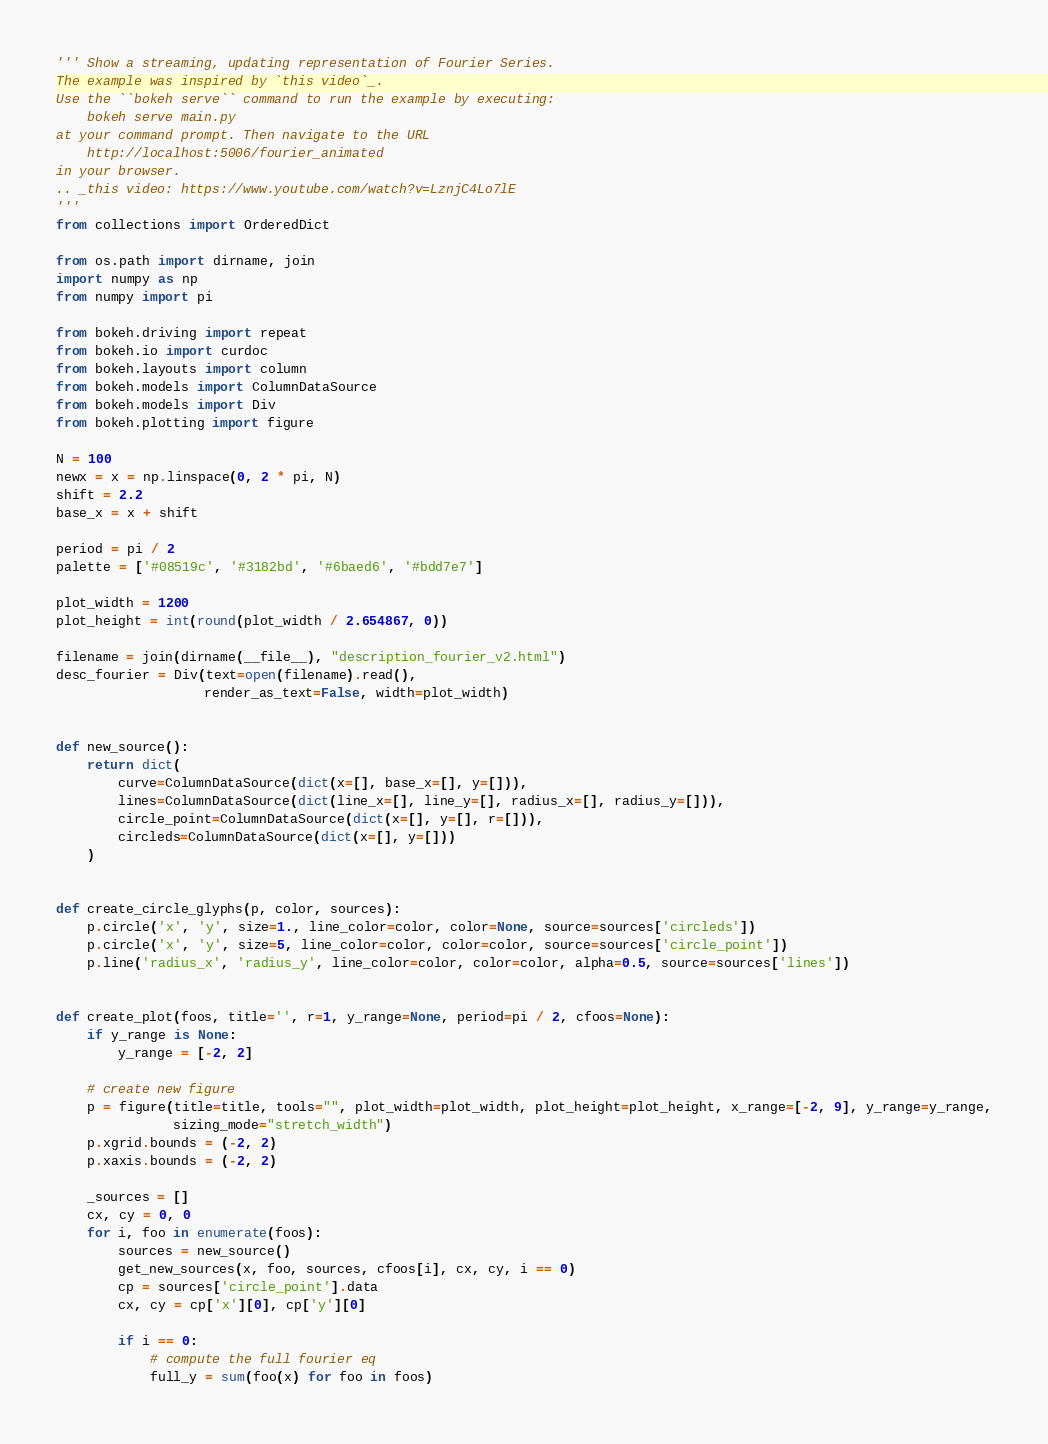Convert code to text. <code><loc_0><loc_0><loc_500><loc_500><_Python_>''' Show a streaming, updating representation of Fourier Series.
The example was inspired by `this video`_.
Use the ``bokeh serve`` command to run the example by executing:
    bokeh serve main.py
at your command prompt. Then navigate to the URL
    http://localhost:5006/fourier_animated
in your browser.
.. _this video: https://www.youtube.com/watch?v=LznjC4Lo7lE
'''
from collections import OrderedDict

from os.path import dirname, join
import numpy as np
from numpy import pi

from bokeh.driving import repeat
from bokeh.io import curdoc
from bokeh.layouts import column
from bokeh.models import ColumnDataSource
from bokeh.models import Div
from bokeh.plotting import figure

N = 100
newx = x = np.linspace(0, 2 * pi, N)
shift = 2.2
base_x = x + shift

period = pi / 2
palette = ['#08519c', '#3182bd', '#6baed6', '#bdd7e7']

plot_width = 1200
plot_height = int(round(plot_width / 2.654867, 0))

filename = join(dirname(__file__), "description_fourier_v2.html")
desc_fourier = Div(text=open(filename).read(),
                   render_as_text=False, width=plot_width)


def new_source():
    return dict(
        curve=ColumnDataSource(dict(x=[], base_x=[], y=[])),
        lines=ColumnDataSource(dict(line_x=[], line_y=[], radius_x=[], radius_y=[])),
        circle_point=ColumnDataSource(dict(x=[], y=[], r=[])),
        circleds=ColumnDataSource(dict(x=[], y=[]))
    )


def create_circle_glyphs(p, color, sources):
    p.circle('x', 'y', size=1., line_color=color, color=None, source=sources['circleds'])
    p.circle('x', 'y', size=5, line_color=color, color=color, source=sources['circle_point'])
    p.line('radius_x', 'radius_y', line_color=color, color=color, alpha=0.5, source=sources['lines'])


def create_plot(foos, title='', r=1, y_range=None, period=pi / 2, cfoos=None):
    if y_range is None:
        y_range = [-2, 2]

    # create new figure
    p = figure(title=title, tools="", plot_width=plot_width, plot_height=plot_height, x_range=[-2, 9], y_range=y_range,
               sizing_mode="stretch_width")
    p.xgrid.bounds = (-2, 2)
    p.xaxis.bounds = (-2, 2)

    _sources = []
    cx, cy = 0, 0
    for i, foo in enumerate(foos):
        sources = new_source()
        get_new_sources(x, foo, sources, cfoos[i], cx, cy, i == 0)
        cp = sources['circle_point'].data
        cx, cy = cp['x'][0], cp['y'][0]

        if i == 0:
            # compute the full fourier eq
            full_y = sum(foo(x) for foo in foos)</code> 